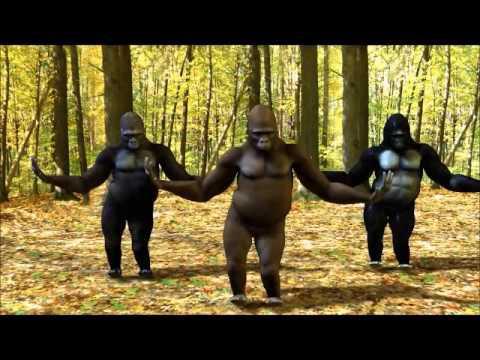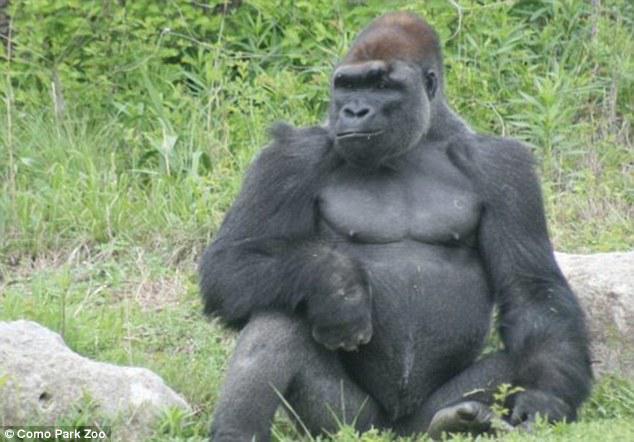The first image is the image on the left, the second image is the image on the right. For the images displayed, is the sentence "A total of four gorillas are shown, and left and right images do not contain the same number of gorillas." factually correct? Answer yes or no. Yes. The first image is the image on the left, the second image is the image on the right. Assess this claim about the two images: "At least one of the gorillas has an open mouth.". Correct or not? Answer yes or no. No. 